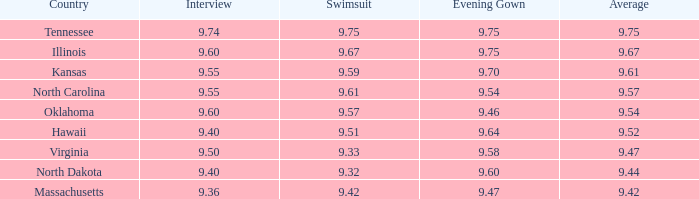What is the swimwear rating when the conversation was 9.75. 